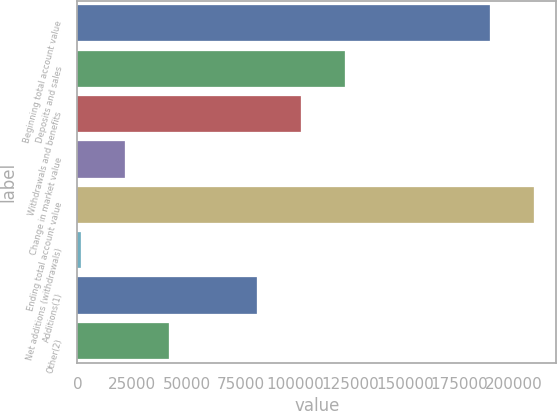Convert chart. <chart><loc_0><loc_0><loc_500><loc_500><bar_chart><fcel>Beginning total account value<fcel>Deposits and sales<fcel>Withdrawals and benefits<fcel>Change in market value<fcel>Ending total account value<fcel>Net additions (withdrawals)<fcel>Additions(1)<fcel>Other(2)<nl><fcel>188961<fcel>122402<fcel>102302<fcel>21901.1<fcel>209061<fcel>1801<fcel>82201.4<fcel>42001.2<nl></chart> 